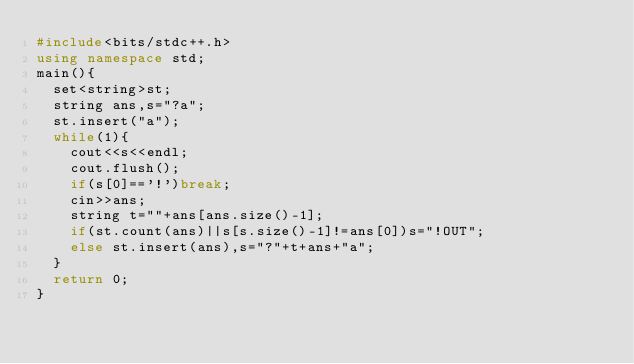Convert code to text. <code><loc_0><loc_0><loc_500><loc_500><_C++_>#include<bits/stdc++.h>
using namespace std;
main(){
  set<string>st;
  string ans,s="?a";
  st.insert("a");
  while(1){
    cout<<s<<endl;
    cout.flush();
    if(s[0]=='!')break;
    cin>>ans;
    string t=""+ans[ans.size()-1];
    if(st.count(ans)||s[s.size()-1]!=ans[0])s="!OUT";
    else st.insert(ans),s="?"+t+ans+"a";
  }
  return 0;
}</code> 